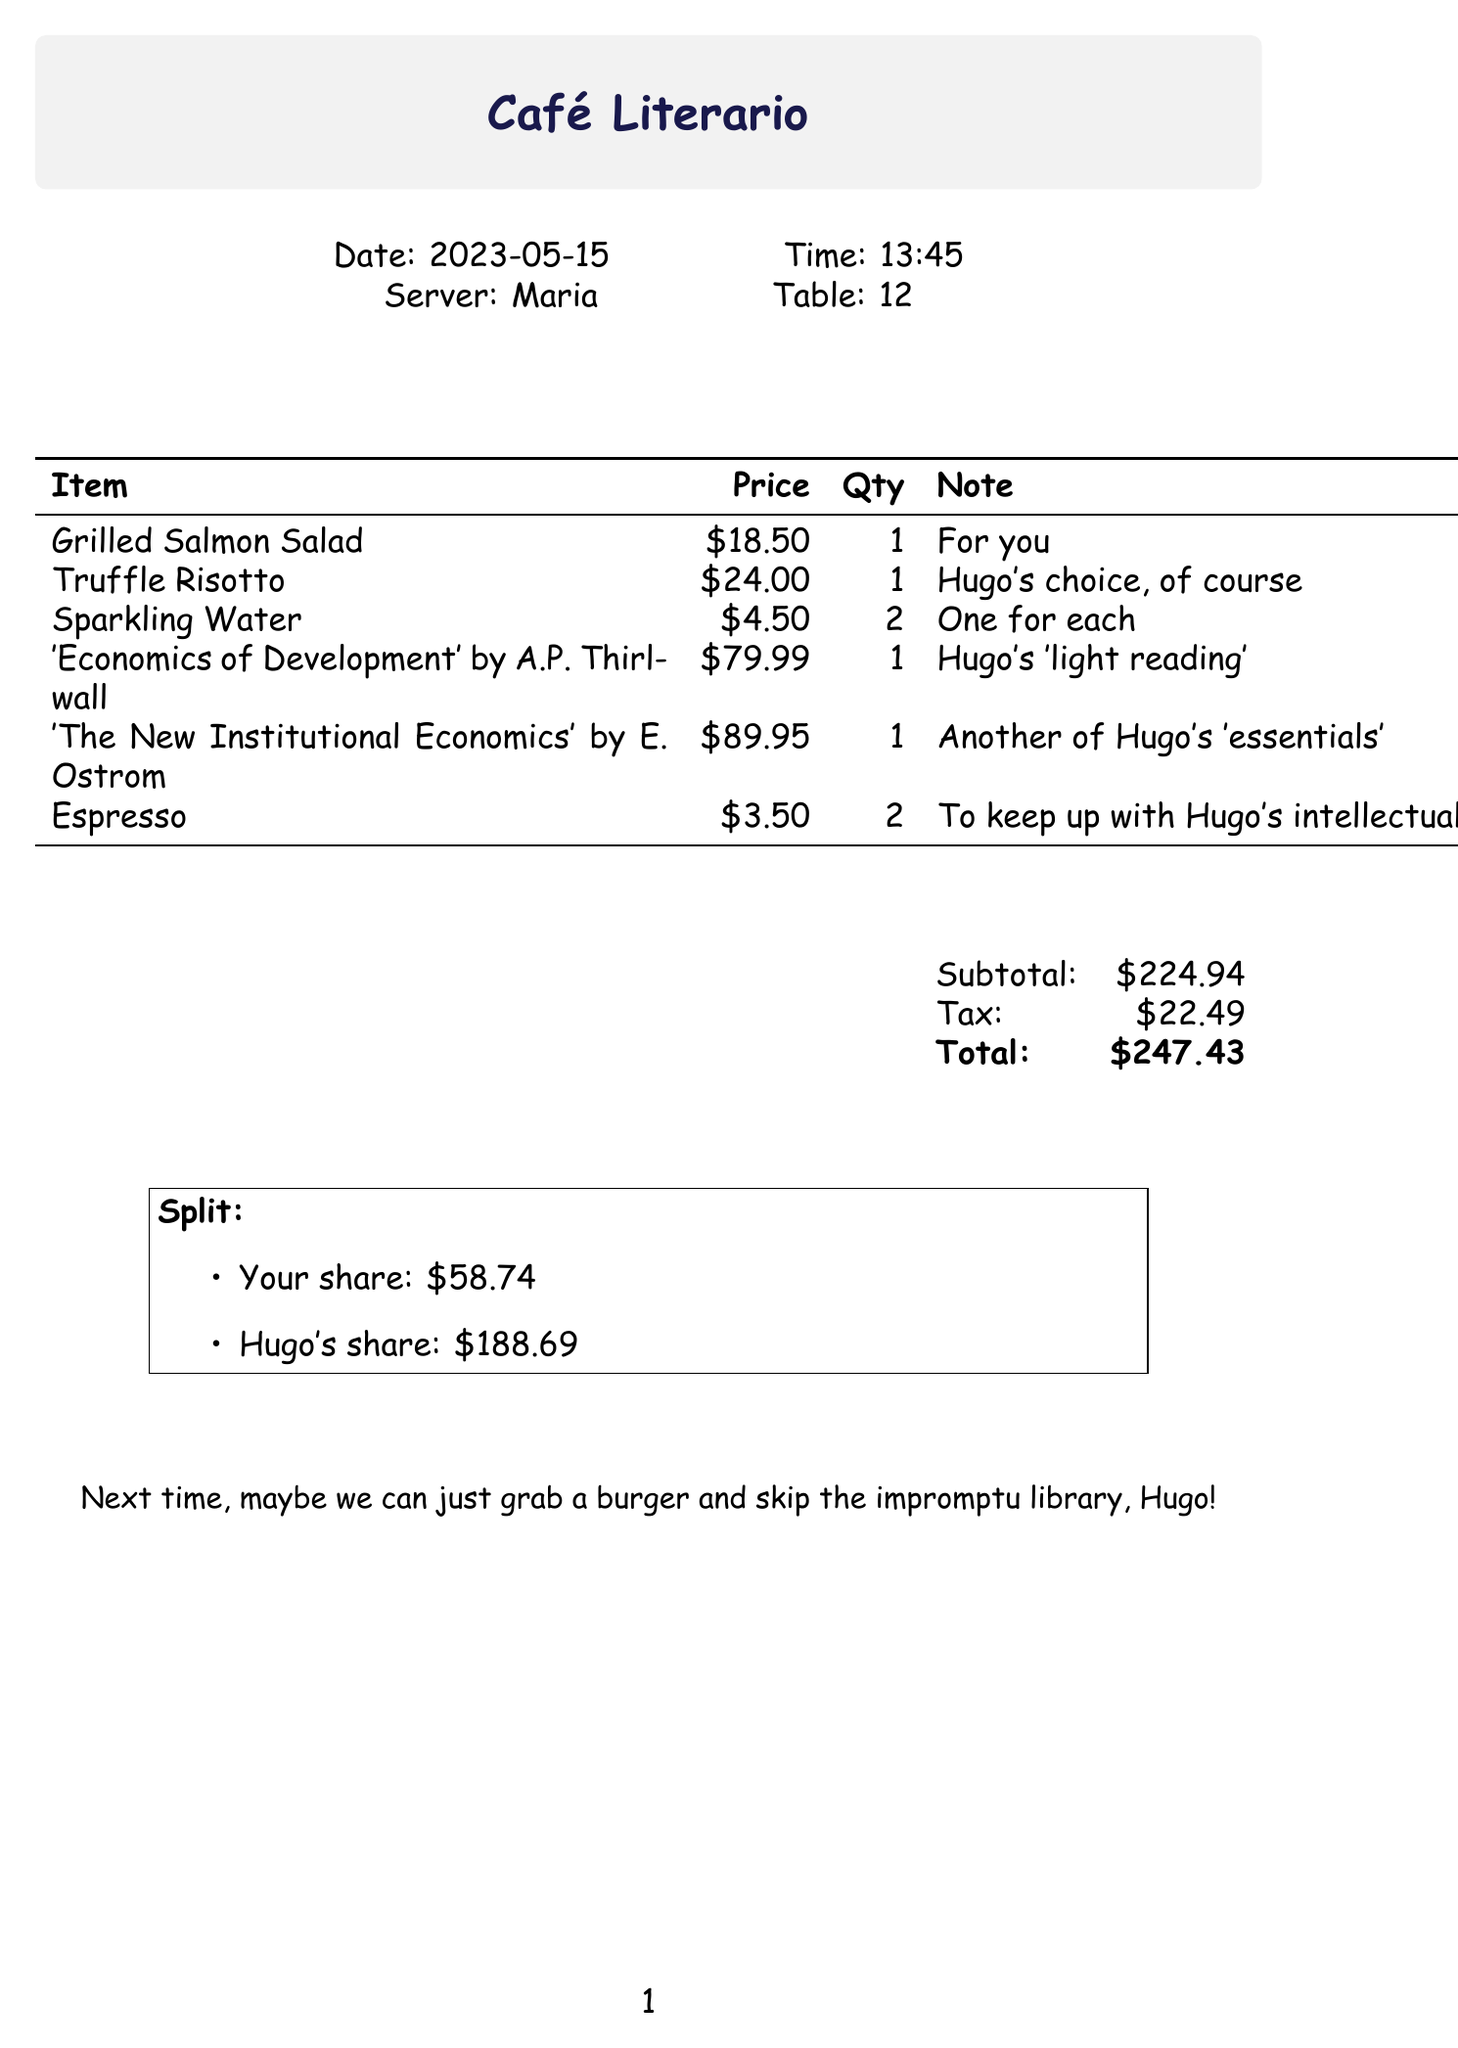What is the restaurant name? The document lists the name of the restaurant at the top.
Answer: Café Literario What date was the lunch meeting? The date of the lunch meeting is mentioned in the document.
Answer: 2023-05-15 Who was the server? The server's name is provided in the document.
Answer: Maria What item did Hugo choose? The document specifies which dish Hugo selected.
Answer: Truffle Risotto How much was the total amount? The total amount is clearly stated in the document.
Answer: $247.43 What is your share of the bill? The document details the split of the bill.
Answer: $58.74 How many items were listed? The count of items is determined by the number of entries in the itemized list.
Answer: 6 What was the price of 'Economics of Development'? The document provides the price of this specific book.
Answer: $79.99 What note is included about the future meeting? The document contains a note regarding future meetings at the bottom.
Answer: Next time, maybe we can just grab a burger and skip the impromptu library, Hugo! 